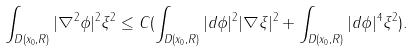Convert formula to latex. <formula><loc_0><loc_0><loc_500><loc_500>\int _ { D ( x _ { 0 } , R ) } | \nabla ^ { 2 } \phi | ^ { 2 } \xi ^ { 2 } \leq C ( \int _ { D ( x _ { 0 } , R ) } | d \phi | ^ { 2 } | \nabla \xi | ^ { 2 } + \int _ { D ( x _ { 0 } , R ) } | d \phi | ^ { 4 } \xi ^ { 2 } ) .</formula> 